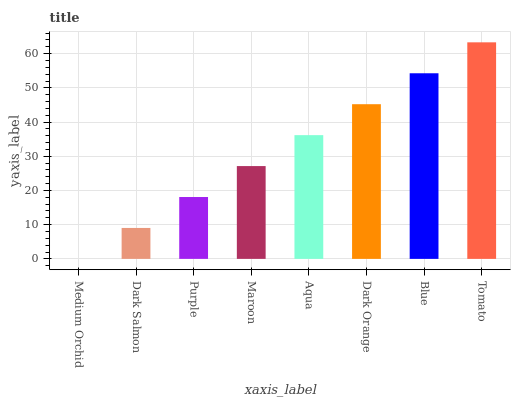Is Medium Orchid the minimum?
Answer yes or no. Yes. Is Tomato the maximum?
Answer yes or no. Yes. Is Dark Salmon the minimum?
Answer yes or no. No. Is Dark Salmon the maximum?
Answer yes or no. No. Is Dark Salmon greater than Medium Orchid?
Answer yes or no. Yes. Is Medium Orchid less than Dark Salmon?
Answer yes or no. Yes. Is Medium Orchid greater than Dark Salmon?
Answer yes or no. No. Is Dark Salmon less than Medium Orchid?
Answer yes or no. No. Is Aqua the high median?
Answer yes or no. Yes. Is Maroon the low median?
Answer yes or no. Yes. Is Tomato the high median?
Answer yes or no. No. Is Dark Orange the low median?
Answer yes or no. No. 